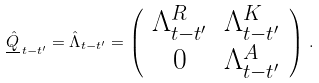<formula> <loc_0><loc_0><loc_500><loc_500>\underline { \hat { Q } } _ { \, t - t ^ { \prime } } = \hat { \Lambda } _ { t - t ^ { \prime } } = \left ( \begin{array} { c c } \Lambda ^ { R } _ { t - t ^ { \prime } } & \Lambda ^ { K } _ { t - t ^ { \prime } } \\ 0 & \Lambda ^ { A } _ { t - t ^ { \prime } } \end{array} \right ) \, .</formula> 